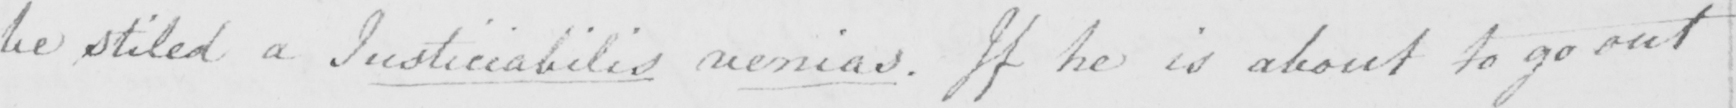Transcribe the text shown in this historical manuscript line. be stiled a and Justiciabilis venias . If he is about to go out 